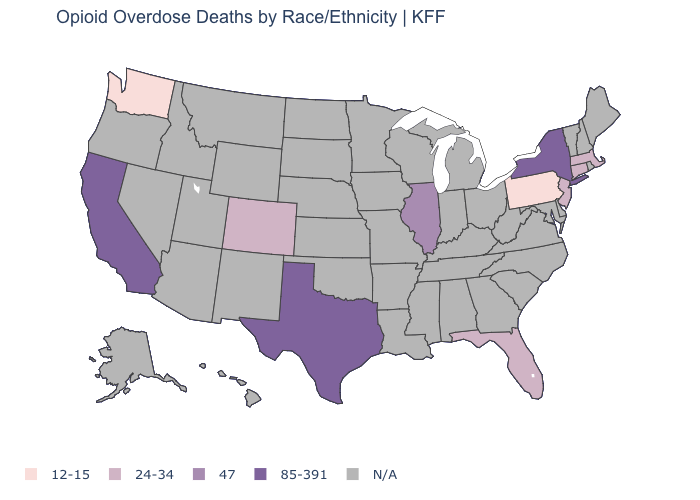What is the lowest value in the Northeast?
Write a very short answer. 12-15. Is the legend a continuous bar?
Concise answer only. No. What is the value of Vermont?
Concise answer only. N/A. What is the value of Wisconsin?
Keep it brief. N/A. Which states have the highest value in the USA?
Be succinct. California, New York, Texas. Is the legend a continuous bar?
Quick response, please. No. Name the states that have a value in the range 12-15?
Keep it brief. Pennsylvania, Washington. Does Washington have the lowest value in the USA?
Write a very short answer. Yes. Which states hav the highest value in the South?
Concise answer only. Texas. Which states have the lowest value in the USA?
Keep it brief. Pennsylvania, Washington. What is the value of Minnesota?
Write a very short answer. N/A. Name the states that have a value in the range N/A?
Quick response, please. Alabama, Alaska, Arizona, Arkansas, Delaware, Georgia, Hawaii, Idaho, Indiana, Iowa, Kansas, Kentucky, Louisiana, Maine, Maryland, Michigan, Minnesota, Mississippi, Missouri, Montana, Nebraska, Nevada, New Hampshire, New Mexico, North Carolina, North Dakota, Ohio, Oklahoma, Oregon, Rhode Island, South Carolina, South Dakota, Tennessee, Utah, Vermont, Virginia, West Virginia, Wisconsin, Wyoming. 